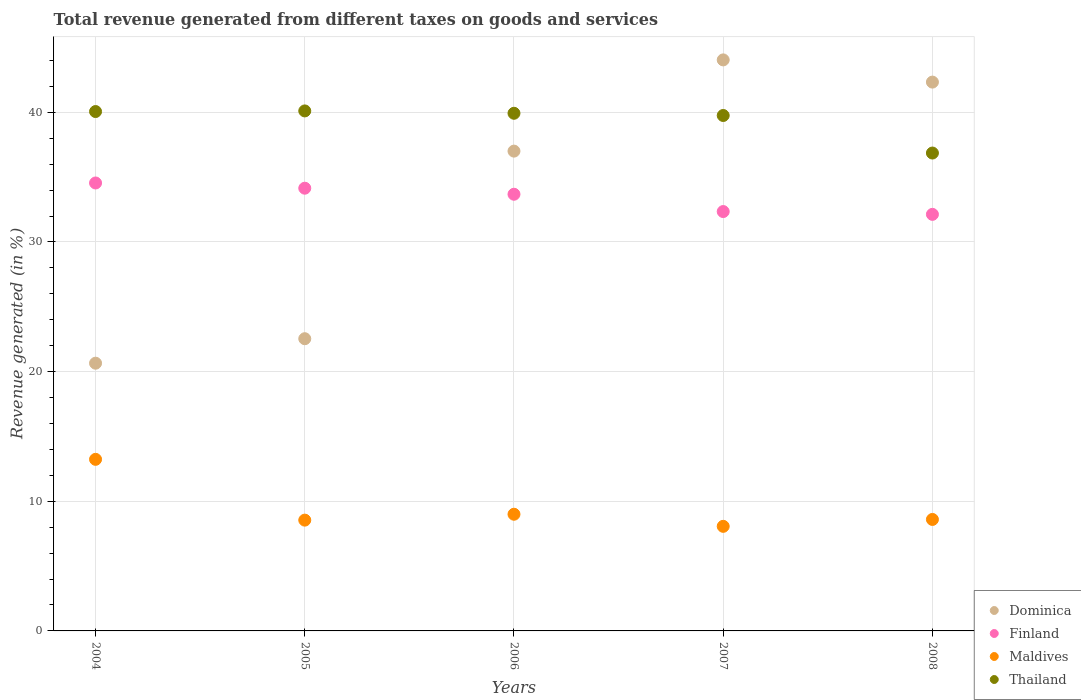What is the total revenue generated in Thailand in 2005?
Offer a terse response. 40.11. Across all years, what is the maximum total revenue generated in Thailand?
Keep it short and to the point. 40.11. Across all years, what is the minimum total revenue generated in Dominica?
Your response must be concise. 20.65. In which year was the total revenue generated in Dominica minimum?
Offer a very short reply. 2004. What is the total total revenue generated in Thailand in the graph?
Ensure brevity in your answer.  196.71. What is the difference between the total revenue generated in Dominica in 2005 and that in 2006?
Your answer should be very brief. -14.47. What is the difference between the total revenue generated in Dominica in 2006 and the total revenue generated in Maldives in 2008?
Ensure brevity in your answer.  28.41. What is the average total revenue generated in Finland per year?
Make the answer very short. 33.37. In the year 2005, what is the difference between the total revenue generated in Thailand and total revenue generated in Finland?
Ensure brevity in your answer.  5.96. In how many years, is the total revenue generated in Dominica greater than 14 %?
Provide a short and direct response. 5. What is the ratio of the total revenue generated in Finland in 2006 to that in 2007?
Your answer should be compact. 1.04. What is the difference between the highest and the second highest total revenue generated in Thailand?
Your response must be concise. 0.05. What is the difference between the highest and the lowest total revenue generated in Finland?
Provide a short and direct response. 2.42. Is the sum of the total revenue generated in Finland in 2004 and 2006 greater than the maximum total revenue generated in Thailand across all years?
Offer a very short reply. Yes. Is the total revenue generated in Finland strictly less than the total revenue generated in Maldives over the years?
Give a very brief answer. No. How many dotlines are there?
Provide a short and direct response. 4. How many years are there in the graph?
Provide a short and direct response. 5. What is the title of the graph?
Your response must be concise. Total revenue generated from different taxes on goods and services. Does "China" appear as one of the legend labels in the graph?
Provide a succinct answer. No. What is the label or title of the Y-axis?
Provide a succinct answer. Revenue generated (in %). What is the Revenue generated (in %) in Dominica in 2004?
Keep it short and to the point. 20.65. What is the Revenue generated (in %) of Finland in 2004?
Ensure brevity in your answer.  34.55. What is the Revenue generated (in %) in Maldives in 2004?
Offer a terse response. 13.23. What is the Revenue generated (in %) of Thailand in 2004?
Your answer should be very brief. 40.06. What is the Revenue generated (in %) in Dominica in 2005?
Ensure brevity in your answer.  22.54. What is the Revenue generated (in %) in Finland in 2005?
Your response must be concise. 34.15. What is the Revenue generated (in %) in Maldives in 2005?
Provide a succinct answer. 8.55. What is the Revenue generated (in %) in Thailand in 2005?
Provide a short and direct response. 40.11. What is the Revenue generated (in %) of Dominica in 2006?
Your answer should be compact. 37.01. What is the Revenue generated (in %) in Finland in 2006?
Provide a short and direct response. 33.68. What is the Revenue generated (in %) of Maldives in 2006?
Provide a short and direct response. 9. What is the Revenue generated (in %) in Thailand in 2006?
Your response must be concise. 39.93. What is the Revenue generated (in %) in Dominica in 2007?
Provide a short and direct response. 44.04. What is the Revenue generated (in %) in Finland in 2007?
Your response must be concise. 32.35. What is the Revenue generated (in %) in Maldives in 2007?
Offer a very short reply. 8.07. What is the Revenue generated (in %) in Thailand in 2007?
Your answer should be compact. 39.76. What is the Revenue generated (in %) in Dominica in 2008?
Your answer should be compact. 42.33. What is the Revenue generated (in %) in Finland in 2008?
Make the answer very short. 32.13. What is the Revenue generated (in %) in Maldives in 2008?
Give a very brief answer. 8.6. What is the Revenue generated (in %) of Thailand in 2008?
Provide a short and direct response. 36.86. Across all years, what is the maximum Revenue generated (in %) of Dominica?
Give a very brief answer. 44.04. Across all years, what is the maximum Revenue generated (in %) of Finland?
Ensure brevity in your answer.  34.55. Across all years, what is the maximum Revenue generated (in %) of Maldives?
Your answer should be compact. 13.23. Across all years, what is the maximum Revenue generated (in %) of Thailand?
Ensure brevity in your answer.  40.11. Across all years, what is the minimum Revenue generated (in %) in Dominica?
Provide a succinct answer. 20.65. Across all years, what is the minimum Revenue generated (in %) of Finland?
Provide a succinct answer. 32.13. Across all years, what is the minimum Revenue generated (in %) of Maldives?
Offer a terse response. 8.07. Across all years, what is the minimum Revenue generated (in %) in Thailand?
Make the answer very short. 36.86. What is the total Revenue generated (in %) of Dominica in the graph?
Offer a terse response. 166.57. What is the total Revenue generated (in %) in Finland in the graph?
Make the answer very short. 166.86. What is the total Revenue generated (in %) in Maldives in the graph?
Offer a terse response. 47.44. What is the total Revenue generated (in %) in Thailand in the graph?
Offer a terse response. 196.71. What is the difference between the Revenue generated (in %) of Dominica in 2004 and that in 2005?
Your response must be concise. -1.89. What is the difference between the Revenue generated (in %) in Finland in 2004 and that in 2005?
Ensure brevity in your answer.  0.4. What is the difference between the Revenue generated (in %) of Maldives in 2004 and that in 2005?
Offer a terse response. 4.69. What is the difference between the Revenue generated (in %) in Thailand in 2004 and that in 2005?
Provide a succinct answer. -0.05. What is the difference between the Revenue generated (in %) in Dominica in 2004 and that in 2006?
Offer a very short reply. -16.36. What is the difference between the Revenue generated (in %) in Finland in 2004 and that in 2006?
Your answer should be very brief. 0.87. What is the difference between the Revenue generated (in %) in Maldives in 2004 and that in 2006?
Offer a very short reply. 4.23. What is the difference between the Revenue generated (in %) in Thailand in 2004 and that in 2006?
Your answer should be compact. 0.13. What is the difference between the Revenue generated (in %) of Dominica in 2004 and that in 2007?
Your answer should be very brief. -23.39. What is the difference between the Revenue generated (in %) in Finland in 2004 and that in 2007?
Offer a very short reply. 2.2. What is the difference between the Revenue generated (in %) in Maldives in 2004 and that in 2007?
Keep it short and to the point. 5.17. What is the difference between the Revenue generated (in %) of Thailand in 2004 and that in 2007?
Keep it short and to the point. 0.3. What is the difference between the Revenue generated (in %) in Dominica in 2004 and that in 2008?
Your answer should be compact. -21.68. What is the difference between the Revenue generated (in %) of Finland in 2004 and that in 2008?
Make the answer very short. 2.42. What is the difference between the Revenue generated (in %) in Maldives in 2004 and that in 2008?
Give a very brief answer. 4.64. What is the difference between the Revenue generated (in %) in Thailand in 2004 and that in 2008?
Give a very brief answer. 3.2. What is the difference between the Revenue generated (in %) in Dominica in 2005 and that in 2006?
Your response must be concise. -14.47. What is the difference between the Revenue generated (in %) of Finland in 2005 and that in 2006?
Keep it short and to the point. 0.47. What is the difference between the Revenue generated (in %) in Maldives in 2005 and that in 2006?
Offer a very short reply. -0.45. What is the difference between the Revenue generated (in %) in Thailand in 2005 and that in 2006?
Ensure brevity in your answer.  0.18. What is the difference between the Revenue generated (in %) of Dominica in 2005 and that in 2007?
Keep it short and to the point. -21.51. What is the difference between the Revenue generated (in %) in Finland in 2005 and that in 2007?
Offer a very short reply. 1.8. What is the difference between the Revenue generated (in %) in Maldives in 2005 and that in 2007?
Keep it short and to the point. 0.48. What is the difference between the Revenue generated (in %) of Thailand in 2005 and that in 2007?
Provide a succinct answer. 0.35. What is the difference between the Revenue generated (in %) of Dominica in 2005 and that in 2008?
Offer a very short reply. -19.79. What is the difference between the Revenue generated (in %) of Finland in 2005 and that in 2008?
Make the answer very short. 2.02. What is the difference between the Revenue generated (in %) in Maldives in 2005 and that in 2008?
Your answer should be compact. -0.05. What is the difference between the Revenue generated (in %) in Thailand in 2005 and that in 2008?
Your answer should be very brief. 3.25. What is the difference between the Revenue generated (in %) in Dominica in 2006 and that in 2007?
Offer a very short reply. -7.04. What is the difference between the Revenue generated (in %) in Finland in 2006 and that in 2007?
Provide a short and direct response. 1.33. What is the difference between the Revenue generated (in %) in Maldives in 2006 and that in 2007?
Keep it short and to the point. 0.93. What is the difference between the Revenue generated (in %) of Thailand in 2006 and that in 2007?
Provide a short and direct response. 0.17. What is the difference between the Revenue generated (in %) in Dominica in 2006 and that in 2008?
Provide a short and direct response. -5.32. What is the difference between the Revenue generated (in %) in Finland in 2006 and that in 2008?
Provide a short and direct response. 1.55. What is the difference between the Revenue generated (in %) of Maldives in 2006 and that in 2008?
Your answer should be very brief. 0.4. What is the difference between the Revenue generated (in %) of Thailand in 2006 and that in 2008?
Your answer should be compact. 3.07. What is the difference between the Revenue generated (in %) in Dominica in 2007 and that in 2008?
Make the answer very short. 1.71. What is the difference between the Revenue generated (in %) in Finland in 2007 and that in 2008?
Give a very brief answer. 0.22. What is the difference between the Revenue generated (in %) of Maldives in 2007 and that in 2008?
Keep it short and to the point. -0.53. What is the difference between the Revenue generated (in %) in Thailand in 2007 and that in 2008?
Give a very brief answer. 2.9. What is the difference between the Revenue generated (in %) of Dominica in 2004 and the Revenue generated (in %) of Finland in 2005?
Keep it short and to the point. -13.5. What is the difference between the Revenue generated (in %) of Dominica in 2004 and the Revenue generated (in %) of Maldives in 2005?
Your answer should be compact. 12.1. What is the difference between the Revenue generated (in %) of Dominica in 2004 and the Revenue generated (in %) of Thailand in 2005?
Your answer should be very brief. -19.46. What is the difference between the Revenue generated (in %) in Finland in 2004 and the Revenue generated (in %) in Maldives in 2005?
Keep it short and to the point. 26.01. What is the difference between the Revenue generated (in %) of Finland in 2004 and the Revenue generated (in %) of Thailand in 2005?
Your answer should be very brief. -5.56. What is the difference between the Revenue generated (in %) of Maldives in 2004 and the Revenue generated (in %) of Thailand in 2005?
Ensure brevity in your answer.  -26.87. What is the difference between the Revenue generated (in %) of Dominica in 2004 and the Revenue generated (in %) of Finland in 2006?
Your answer should be very brief. -13.03. What is the difference between the Revenue generated (in %) of Dominica in 2004 and the Revenue generated (in %) of Maldives in 2006?
Offer a very short reply. 11.65. What is the difference between the Revenue generated (in %) of Dominica in 2004 and the Revenue generated (in %) of Thailand in 2006?
Offer a very short reply. -19.28. What is the difference between the Revenue generated (in %) in Finland in 2004 and the Revenue generated (in %) in Maldives in 2006?
Your response must be concise. 25.55. What is the difference between the Revenue generated (in %) of Finland in 2004 and the Revenue generated (in %) of Thailand in 2006?
Your answer should be compact. -5.38. What is the difference between the Revenue generated (in %) of Maldives in 2004 and the Revenue generated (in %) of Thailand in 2006?
Offer a terse response. -26.69. What is the difference between the Revenue generated (in %) in Dominica in 2004 and the Revenue generated (in %) in Finland in 2007?
Make the answer very short. -11.7. What is the difference between the Revenue generated (in %) in Dominica in 2004 and the Revenue generated (in %) in Maldives in 2007?
Ensure brevity in your answer.  12.58. What is the difference between the Revenue generated (in %) of Dominica in 2004 and the Revenue generated (in %) of Thailand in 2007?
Give a very brief answer. -19.11. What is the difference between the Revenue generated (in %) of Finland in 2004 and the Revenue generated (in %) of Maldives in 2007?
Provide a short and direct response. 26.48. What is the difference between the Revenue generated (in %) in Finland in 2004 and the Revenue generated (in %) in Thailand in 2007?
Offer a very short reply. -5.21. What is the difference between the Revenue generated (in %) of Maldives in 2004 and the Revenue generated (in %) of Thailand in 2007?
Provide a short and direct response. -26.52. What is the difference between the Revenue generated (in %) of Dominica in 2004 and the Revenue generated (in %) of Finland in 2008?
Your answer should be compact. -11.48. What is the difference between the Revenue generated (in %) of Dominica in 2004 and the Revenue generated (in %) of Maldives in 2008?
Make the answer very short. 12.05. What is the difference between the Revenue generated (in %) of Dominica in 2004 and the Revenue generated (in %) of Thailand in 2008?
Your response must be concise. -16.21. What is the difference between the Revenue generated (in %) in Finland in 2004 and the Revenue generated (in %) in Maldives in 2008?
Your answer should be compact. 25.95. What is the difference between the Revenue generated (in %) of Finland in 2004 and the Revenue generated (in %) of Thailand in 2008?
Offer a terse response. -2.31. What is the difference between the Revenue generated (in %) in Maldives in 2004 and the Revenue generated (in %) in Thailand in 2008?
Provide a succinct answer. -23.63. What is the difference between the Revenue generated (in %) in Dominica in 2005 and the Revenue generated (in %) in Finland in 2006?
Your response must be concise. -11.14. What is the difference between the Revenue generated (in %) in Dominica in 2005 and the Revenue generated (in %) in Maldives in 2006?
Provide a succinct answer. 13.54. What is the difference between the Revenue generated (in %) in Dominica in 2005 and the Revenue generated (in %) in Thailand in 2006?
Your answer should be compact. -17.39. What is the difference between the Revenue generated (in %) of Finland in 2005 and the Revenue generated (in %) of Maldives in 2006?
Ensure brevity in your answer.  25.15. What is the difference between the Revenue generated (in %) in Finland in 2005 and the Revenue generated (in %) in Thailand in 2006?
Provide a succinct answer. -5.78. What is the difference between the Revenue generated (in %) of Maldives in 2005 and the Revenue generated (in %) of Thailand in 2006?
Offer a terse response. -31.38. What is the difference between the Revenue generated (in %) of Dominica in 2005 and the Revenue generated (in %) of Finland in 2007?
Offer a terse response. -9.81. What is the difference between the Revenue generated (in %) of Dominica in 2005 and the Revenue generated (in %) of Maldives in 2007?
Your answer should be compact. 14.47. What is the difference between the Revenue generated (in %) in Dominica in 2005 and the Revenue generated (in %) in Thailand in 2007?
Make the answer very short. -17.22. What is the difference between the Revenue generated (in %) in Finland in 2005 and the Revenue generated (in %) in Maldives in 2007?
Your response must be concise. 26.08. What is the difference between the Revenue generated (in %) of Finland in 2005 and the Revenue generated (in %) of Thailand in 2007?
Make the answer very short. -5.61. What is the difference between the Revenue generated (in %) of Maldives in 2005 and the Revenue generated (in %) of Thailand in 2007?
Your answer should be very brief. -31.21. What is the difference between the Revenue generated (in %) in Dominica in 2005 and the Revenue generated (in %) in Finland in 2008?
Ensure brevity in your answer.  -9.59. What is the difference between the Revenue generated (in %) in Dominica in 2005 and the Revenue generated (in %) in Maldives in 2008?
Ensure brevity in your answer.  13.94. What is the difference between the Revenue generated (in %) in Dominica in 2005 and the Revenue generated (in %) in Thailand in 2008?
Ensure brevity in your answer.  -14.32. What is the difference between the Revenue generated (in %) in Finland in 2005 and the Revenue generated (in %) in Maldives in 2008?
Provide a succinct answer. 25.55. What is the difference between the Revenue generated (in %) in Finland in 2005 and the Revenue generated (in %) in Thailand in 2008?
Offer a very short reply. -2.71. What is the difference between the Revenue generated (in %) in Maldives in 2005 and the Revenue generated (in %) in Thailand in 2008?
Your answer should be compact. -28.31. What is the difference between the Revenue generated (in %) in Dominica in 2006 and the Revenue generated (in %) in Finland in 2007?
Offer a very short reply. 4.66. What is the difference between the Revenue generated (in %) of Dominica in 2006 and the Revenue generated (in %) of Maldives in 2007?
Provide a short and direct response. 28.94. What is the difference between the Revenue generated (in %) in Dominica in 2006 and the Revenue generated (in %) in Thailand in 2007?
Make the answer very short. -2.75. What is the difference between the Revenue generated (in %) in Finland in 2006 and the Revenue generated (in %) in Maldives in 2007?
Offer a terse response. 25.61. What is the difference between the Revenue generated (in %) in Finland in 2006 and the Revenue generated (in %) in Thailand in 2007?
Your answer should be compact. -6.07. What is the difference between the Revenue generated (in %) in Maldives in 2006 and the Revenue generated (in %) in Thailand in 2007?
Make the answer very short. -30.76. What is the difference between the Revenue generated (in %) of Dominica in 2006 and the Revenue generated (in %) of Finland in 2008?
Provide a succinct answer. 4.88. What is the difference between the Revenue generated (in %) in Dominica in 2006 and the Revenue generated (in %) in Maldives in 2008?
Your response must be concise. 28.41. What is the difference between the Revenue generated (in %) in Dominica in 2006 and the Revenue generated (in %) in Thailand in 2008?
Keep it short and to the point. 0.15. What is the difference between the Revenue generated (in %) of Finland in 2006 and the Revenue generated (in %) of Maldives in 2008?
Ensure brevity in your answer.  25.08. What is the difference between the Revenue generated (in %) in Finland in 2006 and the Revenue generated (in %) in Thailand in 2008?
Your answer should be very brief. -3.18. What is the difference between the Revenue generated (in %) of Maldives in 2006 and the Revenue generated (in %) of Thailand in 2008?
Provide a short and direct response. -27.86. What is the difference between the Revenue generated (in %) in Dominica in 2007 and the Revenue generated (in %) in Finland in 2008?
Offer a very short reply. 11.91. What is the difference between the Revenue generated (in %) of Dominica in 2007 and the Revenue generated (in %) of Maldives in 2008?
Ensure brevity in your answer.  35.45. What is the difference between the Revenue generated (in %) in Dominica in 2007 and the Revenue generated (in %) in Thailand in 2008?
Offer a terse response. 7.18. What is the difference between the Revenue generated (in %) of Finland in 2007 and the Revenue generated (in %) of Maldives in 2008?
Keep it short and to the point. 23.75. What is the difference between the Revenue generated (in %) in Finland in 2007 and the Revenue generated (in %) in Thailand in 2008?
Keep it short and to the point. -4.51. What is the difference between the Revenue generated (in %) in Maldives in 2007 and the Revenue generated (in %) in Thailand in 2008?
Your response must be concise. -28.79. What is the average Revenue generated (in %) in Dominica per year?
Offer a terse response. 33.31. What is the average Revenue generated (in %) in Finland per year?
Your answer should be compact. 33.37. What is the average Revenue generated (in %) of Maldives per year?
Make the answer very short. 9.49. What is the average Revenue generated (in %) in Thailand per year?
Your response must be concise. 39.34. In the year 2004, what is the difference between the Revenue generated (in %) in Dominica and Revenue generated (in %) in Finland?
Your response must be concise. -13.9. In the year 2004, what is the difference between the Revenue generated (in %) in Dominica and Revenue generated (in %) in Maldives?
Make the answer very short. 7.42. In the year 2004, what is the difference between the Revenue generated (in %) in Dominica and Revenue generated (in %) in Thailand?
Give a very brief answer. -19.41. In the year 2004, what is the difference between the Revenue generated (in %) in Finland and Revenue generated (in %) in Maldives?
Offer a terse response. 21.32. In the year 2004, what is the difference between the Revenue generated (in %) of Finland and Revenue generated (in %) of Thailand?
Your answer should be compact. -5.51. In the year 2004, what is the difference between the Revenue generated (in %) in Maldives and Revenue generated (in %) in Thailand?
Provide a succinct answer. -26.83. In the year 2005, what is the difference between the Revenue generated (in %) of Dominica and Revenue generated (in %) of Finland?
Offer a terse response. -11.61. In the year 2005, what is the difference between the Revenue generated (in %) in Dominica and Revenue generated (in %) in Maldives?
Offer a terse response. 13.99. In the year 2005, what is the difference between the Revenue generated (in %) of Dominica and Revenue generated (in %) of Thailand?
Your answer should be very brief. -17.57. In the year 2005, what is the difference between the Revenue generated (in %) in Finland and Revenue generated (in %) in Maldives?
Keep it short and to the point. 25.6. In the year 2005, what is the difference between the Revenue generated (in %) in Finland and Revenue generated (in %) in Thailand?
Provide a short and direct response. -5.96. In the year 2005, what is the difference between the Revenue generated (in %) in Maldives and Revenue generated (in %) in Thailand?
Your response must be concise. -31.56. In the year 2006, what is the difference between the Revenue generated (in %) of Dominica and Revenue generated (in %) of Finland?
Your response must be concise. 3.33. In the year 2006, what is the difference between the Revenue generated (in %) of Dominica and Revenue generated (in %) of Maldives?
Make the answer very short. 28.01. In the year 2006, what is the difference between the Revenue generated (in %) in Dominica and Revenue generated (in %) in Thailand?
Offer a terse response. -2.92. In the year 2006, what is the difference between the Revenue generated (in %) of Finland and Revenue generated (in %) of Maldives?
Your response must be concise. 24.68. In the year 2006, what is the difference between the Revenue generated (in %) in Finland and Revenue generated (in %) in Thailand?
Provide a succinct answer. -6.25. In the year 2006, what is the difference between the Revenue generated (in %) in Maldives and Revenue generated (in %) in Thailand?
Your answer should be compact. -30.93. In the year 2007, what is the difference between the Revenue generated (in %) in Dominica and Revenue generated (in %) in Finland?
Your response must be concise. 11.7. In the year 2007, what is the difference between the Revenue generated (in %) of Dominica and Revenue generated (in %) of Maldives?
Your answer should be very brief. 35.98. In the year 2007, what is the difference between the Revenue generated (in %) of Dominica and Revenue generated (in %) of Thailand?
Your answer should be very brief. 4.29. In the year 2007, what is the difference between the Revenue generated (in %) of Finland and Revenue generated (in %) of Maldives?
Keep it short and to the point. 24.28. In the year 2007, what is the difference between the Revenue generated (in %) in Finland and Revenue generated (in %) in Thailand?
Make the answer very short. -7.41. In the year 2007, what is the difference between the Revenue generated (in %) of Maldives and Revenue generated (in %) of Thailand?
Your answer should be compact. -31.69. In the year 2008, what is the difference between the Revenue generated (in %) of Dominica and Revenue generated (in %) of Finland?
Offer a very short reply. 10.2. In the year 2008, what is the difference between the Revenue generated (in %) of Dominica and Revenue generated (in %) of Maldives?
Give a very brief answer. 33.73. In the year 2008, what is the difference between the Revenue generated (in %) of Dominica and Revenue generated (in %) of Thailand?
Your response must be concise. 5.47. In the year 2008, what is the difference between the Revenue generated (in %) of Finland and Revenue generated (in %) of Maldives?
Your answer should be very brief. 23.53. In the year 2008, what is the difference between the Revenue generated (in %) in Finland and Revenue generated (in %) in Thailand?
Your response must be concise. -4.73. In the year 2008, what is the difference between the Revenue generated (in %) of Maldives and Revenue generated (in %) of Thailand?
Ensure brevity in your answer.  -28.26. What is the ratio of the Revenue generated (in %) in Dominica in 2004 to that in 2005?
Give a very brief answer. 0.92. What is the ratio of the Revenue generated (in %) of Finland in 2004 to that in 2005?
Your answer should be compact. 1.01. What is the ratio of the Revenue generated (in %) in Maldives in 2004 to that in 2005?
Offer a terse response. 1.55. What is the ratio of the Revenue generated (in %) in Dominica in 2004 to that in 2006?
Your answer should be very brief. 0.56. What is the ratio of the Revenue generated (in %) in Finland in 2004 to that in 2006?
Your answer should be compact. 1.03. What is the ratio of the Revenue generated (in %) in Maldives in 2004 to that in 2006?
Provide a short and direct response. 1.47. What is the ratio of the Revenue generated (in %) of Dominica in 2004 to that in 2007?
Your response must be concise. 0.47. What is the ratio of the Revenue generated (in %) in Finland in 2004 to that in 2007?
Your answer should be compact. 1.07. What is the ratio of the Revenue generated (in %) of Maldives in 2004 to that in 2007?
Your response must be concise. 1.64. What is the ratio of the Revenue generated (in %) of Thailand in 2004 to that in 2007?
Make the answer very short. 1.01. What is the ratio of the Revenue generated (in %) in Dominica in 2004 to that in 2008?
Offer a very short reply. 0.49. What is the ratio of the Revenue generated (in %) of Finland in 2004 to that in 2008?
Give a very brief answer. 1.08. What is the ratio of the Revenue generated (in %) of Maldives in 2004 to that in 2008?
Give a very brief answer. 1.54. What is the ratio of the Revenue generated (in %) of Thailand in 2004 to that in 2008?
Your answer should be compact. 1.09. What is the ratio of the Revenue generated (in %) in Dominica in 2005 to that in 2006?
Provide a short and direct response. 0.61. What is the ratio of the Revenue generated (in %) in Finland in 2005 to that in 2006?
Your answer should be compact. 1.01. What is the ratio of the Revenue generated (in %) of Maldives in 2005 to that in 2006?
Offer a very short reply. 0.95. What is the ratio of the Revenue generated (in %) in Thailand in 2005 to that in 2006?
Provide a succinct answer. 1. What is the ratio of the Revenue generated (in %) of Dominica in 2005 to that in 2007?
Provide a succinct answer. 0.51. What is the ratio of the Revenue generated (in %) of Finland in 2005 to that in 2007?
Give a very brief answer. 1.06. What is the ratio of the Revenue generated (in %) of Maldives in 2005 to that in 2007?
Make the answer very short. 1.06. What is the ratio of the Revenue generated (in %) in Thailand in 2005 to that in 2007?
Ensure brevity in your answer.  1.01. What is the ratio of the Revenue generated (in %) in Dominica in 2005 to that in 2008?
Your answer should be very brief. 0.53. What is the ratio of the Revenue generated (in %) of Finland in 2005 to that in 2008?
Provide a succinct answer. 1.06. What is the ratio of the Revenue generated (in %) of Thailand in 2005 to that in 2008?
Make the answer very short. 1.09. What is the ratio of the Revenue generated (in %) in Dominica in 2006 to that in 2007?
Your answer should be compact. 0.84. What is the ratio of the Revenue generated (in %) of Finland in 2006 to that in 2007?
Offer a terse response. 1.04. What is the ratio of the Revenue generated (in %) of Maldives in 2006 to that in 2007?
Your response must be concise. 1.12. What is the ratio of the Revenue generated (in %) in Dominica in 2006 to that in 2008?
Your answer should be compact. 0.87. What is the ratio of the Revenue generated (in %) of Finland in 2006 to that in 2008?
Your response must be concise. 1.05. What is the ratio of the Revenue generated (in %) in Maldives in 2006 to that in 2008?
Provide a short and direct response. 1.05. What is the ratio of the Revenue generated (in %) in Thailand in 2006 to that in 2008?
Provide a short and direct response. 1.08. What is the ratio of the Revenue generated (in %) of Dominica in 2007 to that in 2008?
Offer a terse response. 1.04. What is the ratio of the Revenue generated (in %) in Maldives in 2007 to that in 2008?
Ensure brevity in your answer.  0.94. What is the ratio of the Revenue generated (in %) of Thailand in 2007 to that in 2008?
Give a very brief answer. 1.08. What is the difference between the highest and the second highest Revenue generated (in %) of Dominica?
Offer a terse response. 1.71. What is the difference between the highest and the second highest Revenue generated (in %) of Finland?
Your answer should be very brief. 0.4. What is the difference between the highest and the second highest Revenue generated (in %) in Maldives?
Your answer should be compact. 4.23. What is the difference between the highest and the second highest Revenue generated (in %) of Thailand?
Offer a very short reply. 0.05. What is the difference between the highest and the lowest Revenue generated (in %) of Dominica?
Your response must be concise. 23.39. What is the difference between the highest and the lowest Revenue generated (in %) in Finland?
Provide a succinct answer. 2.42. What is the difference between the highest and the lowest Revenue generated (in %) in Maldives?
Offer a very short reply. 5.17. What is the difference between the highest and the lowest Revenue generated (in %) of Thailand?
Make the answer very short. 3.25. 